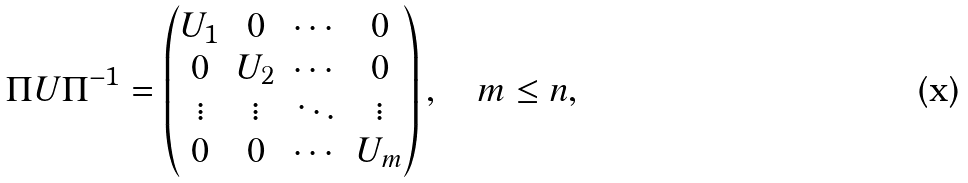Convert formula to latex. <formula><loc_0><loc_0><loc_500><loc_500>\Pi U \Pi ^ { - 1 } = \begin{pmatrix} U _ { 1 } & 0 & \cdots & 0 \\ 0 & U _ { 2 } & \cdots & 0 \\ \vdots & \vdots & \ddots & \vdots \\ 0 & 0 & \cdots & U _ { m } \end{pmatrix} , \quad m \leq n ,</formula> 